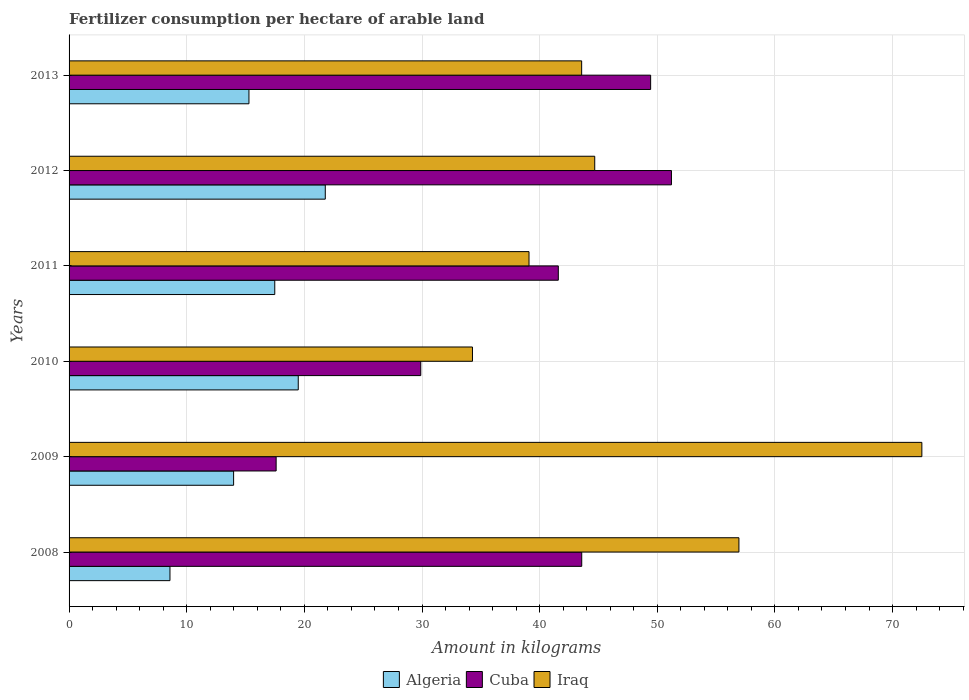How many groups of bars are there?
Offer a very short reply. 6. Are the number of bars per tick equal to the number of legend labels?
Offer a terse response. Yes. Are the number of bars on each tick of the Y-axis equal?
Provide a succinct answer. Yes. What is the amount of fertilizer consumption in Iraq in 2012?
Offer a terse response. 44.68. Across all years, what is the maximum amount of fertilizer consumption in Algeria?
Make the answer very short. 21.78. Across all years, what is the minimum amount of fertilizer consumption in Cuba?
Your response must be concise. 17.6. In which year was the amount of fertilizer consumption in Iraq minimum?
Your response must be concise. 2010. What is the total amount of fertilizer consumption in Algeria in the graph?
Offer a very short reply. 96.6. What is the difference between the amount of fertilizer consumption in Algeria in 2009 and that in 2011?
Keep it short and to the point. -3.5. What is the difference between the amount of fertilizer consumption in Cuba in 2011 and the amount of fertilizer consumption in Algeria in 2013?
Provide a short and direct response. 26.3. What is the average amount of fertilizer consumption in Cuba per year?
Provide a short and direct response. 38.88. In the year 2013, what is the difference between the amount of fertilizer consumption in Iraq and amount of fertilizer consumption in Cuba?
Provide a succinct answer. -5.86. In how many years, is the amount of fertilizer consumption in Cuba greater than 14 kg?
Make the answer very short. 6. What is the ratio of the amount of fertilizer consumption in Iraq in 2009 to that in 2013?
Make the answer very short. 1.66. Is the amount of fertilizer consumption in Algeria in 2010 less than that in 2012?
Offer a very short reply. Yes. Is the difference between the amount of fertilizer consumption in Iraq in 2008 and 2012 greater than the difference between the amount of fertilizer consumption in Cuba in 2008 and 2012?
Ensure brevity in your answer.  Yes. What is the difference between the highest and the second highest amount of fertilizer consumption in Algeria?
Provide a succinct answer. 2.3. What is the difference between the highest and the lowest amount of fertilizer consumption in Cuba?
Make the answer very short. 33.6. What does the 2nd bar from the top in 2013 represents?
Ensure brevity in your answer.  Cuba. What does the 2nd bar from the bottom in 2008 represents?
Make the answer very short. Cuba. Is it the case that in every year, the sum of the amount of fertilizer consumption in Iraq and amount of fertilizer consumption in Algeria is greater than the amount of fertilizer consumption in Cuba?
Ensure brevity in your answer.  Yes. How many bars are there?
Provide a short and direct response. 18. How many years are there in the graph?
Keep it short and to the point. 6. Are the values on the major ticks of X-axis written in scientific E-notation?
Your answer should be compact. No. Where does the legend appear in the graph?
Offer a very short reply. Bottom center. How many legend labels are there?
Your answer should be compact. 3. How are the legend labels stacked?
Your response must be concise. Horizontal. What is the title of the graph?
Give a very brief answer. Fertilizer consumption per hectare of arable land. What is the label or title of the X-axis?
Your response must be concise. Amount in kilograms. What is the Amount in kilograms of Algeria in 2008?
Provide a succinct answer. 8.58. What is the Amount in kilograms of Cuba in 2008?
Offer a very short reply. 43.58. What is the Amount in kilograms of Iraq in 2008?
Your response must be concise. 56.94. What is the Amount in kilograms in Algeria in 2009?
Offer a very short reply. 13.99. What is the Amount in kilograms in Cuba in 2009?
Your answer should be very brief. 17.6. What is the Amount in kilograms of Iraq in 2009?
Your response must be concise. 72.49. What is the Amount in kilograms in Algeria in 2010?
Make the answer very short. 19.48. What is the Amount in kilograms of Cuba in 2010?
Provide a short and direct response. 29.9. What is the Amount in kilograms of Iraq in 2010?
Provide a succinct answer. 34.29. What is the Amount in kilograms of Algeria in 2011?
Your answer should be very brief. 17.49. What is the Amount in kilograms in Cuba in 2011?
Give a very brief answer. 41.59. What is the Amount in kilograms of Iraq in 2011?
Provide a succinct answer. 39.1. What is the Amount in kilograms in Algeria in 2012?
Offer a very short reply. 21.78. What is the Amount in kilograms of Cuba in 2012?
Ensure brevity in your answer.  51.2. What is the Amount in kilograms of Iraq in 2012?
Provide a succinct answer. 44.68. What is the Amount in kilograms in Algeria in 2013?
Provide a short and direct response. 15.29. What is the Amount in kilograms in Cuba in 2013?
Your response must be concise. 49.44. What is the Amount in kilograms of Iraq in 2013?
Your response must be concise. 43.57. Across all years, what is the maximum Amount in kilograms in Algeria?
Ensure brevity in your answer.  21.78. Across all years, what is the maximum Amount in kilograms in Cuba?
Offer a terse response. 51.2. Across all years, what is the maximum Amount in kilograms of Iraq?
Offer a very short reply. 72.49. Across all years, what is the minimum Amount in kilograms of Algeria?
Offer a terse response. 8.58. Across all years, what is the minimum Amount in kilograms of Cuba?
Give a very brief answer. 17.6. Across all years, what is the minimum Amount in kilograms of Iraq?
Your answer should be compact. 34.29. What is the total Amount in kilograms in Algeria in the graph?
Keep it short and to the point. 96.6. What is the total Amount in kilograms in Cuba in the graph?
Ensure brevity in your answer.  233.3. What is the total Amount in kilograms of Iraq in the graph?
Your response must be concise. 291.07. What is the difference between the Amount in kilograms in Algeria in 2008 and that in 2009?
Ensure brevity in your answer.  -5.41. What is the difference between the Amount in kilograms in Cuba in 2008 and that in 2009?
Your answer should be compact. 25.98. What is the difference between the Amount in kilograms of Iraq in 2008 and that in 2009?
Offer a terse response. -15.55. What is the difference between the Amount in kilograms of Algeria in 2008 and that in 2010?
Ensure brevity in your answer.  -10.9. What is the difference between the Amount in kilograms in Cuba in 2008 and that in 2010?
Give a very brief answer. 13.68. What is the difference between the Amount in kilograms of Iraq in 2008 and that in 2010?
Your answer should be very brief. 22.65. What is the difference between the Amount in kilograms in Algeria in 2008 and that in 2011?
Your answer should be very brief. -8.91. What is the difference between the Amount in kilograms of Cuba in 2008 and that in 2011?
Ensure brevity in your answer.  1.99. What is the difference between the Amount in kilograms of Iraq in 2008 and that in 2011?
Provide a succinct answer. 17.84. What is the difference between the Amount in kilograms in Algeria in 2008 and that in 2012?
Provide a short and direct response. -13.2. What is the difference between the Amount in kilograms of Cuba in 2008 and that in 2012?
Your answer should be very brief. -7.63. What is the difference between the Amount in kilograms in Iraq in 2008 and that in 2012?
Offer a terse response. 12.26. What is the difference between the Amount in kilograms in Algeria in 2008 and that in 2013?
Your response must be concise. -6.71. What is the difference between the Amount in kilograms in Cuba in 2008 and that in 2013?
Your answer should be compact. -5.86. What is the difference between the Amount in kilograms in Iraq in 2008 and that in 2013?
Provide a succinct answer. 13.37. What is the difference between the Amount in kilograms of Algeria in 2009 and that in 2010?
Offer a very short reply. -5.49. What is the difference between the Amount in kilograms of Cuba in 2009 and that in 2010?
Provide a short and direct response. -12.29. What is the difference between the Amount in kilograms of Iraq in 2009 and that in 2010?
Provide a short and direct response. 38.2. What is the difference between the Amount in kilograms of Algeria in 2009 and that in 2011?
Ensure brevity in your answer.  -3.5. What is the difference between the Amount in kilograms of Cuba in 2009 and that in 2011?
Give a very brief answer. -23.99. What is the difference between the Amount in kilograms in Iraq in 2009 and that in 2011?
Keep it short and to the point. 33.39. What is the difference between the Amount in kilograms of Algeria in 2009 and that in 2012?
Give a very brief answer. -7.79. What is the difference between the Amount in kilograms of Cuba in 2009 and that in 2012?
Make the answer very short. -33.6. What is the difference between the Amount in kilograms of Iraq in 2009 and that in 2012?
Make the answer very short. 27.81. What is the difference between the Amount in kilograms of Algeria in 2009 and that in 2013?
Provide a succinct answer. -1.3. What is the difference between the Amount in kilograms of Cuba in 2009 and that in 2013?
Your response must be concise. -31.83. What is the difference between the Amount in kilograms of Iraq in 2009 and that in 2013?
Ensure brevity in your answer.  28.92. What is the difference between the Amount in kilograms of Algeria in 2010 and that in 2011?
Offer a terse response. 2. What is the difference between the Amount in kilograms in Cuba in 2010 and that in 2011?
Your response must be concise. -11.69. What is the difference between the Amount in kilograms in Iraq in 2010 and that in 2011?
Provide a short and direct response. -4.81. What is the difference between the Amount in kilograms in Algeria in 2010 and that in 2012?
Your response must be concise. -2.3. What is the difference between the Amount in kilograms of Cuba in 2010 and that in 2012?
Your answer should be very brief. -21.31. What is the difference between the Amount in kilograms in Iraq in 2010 and that in 2012?
Ensure brevity in your answer.  -10.39. What is the difference between the Amount in kilograms in Algeria in 2010 and that in 2013?
Your response must be concise. 4.19. What is the difference between the Amount in kilograms in Cuba in 2010 and that in 2013?
Offer a terse response. -19.54. What is the difference between the Amount in kilograms in Iraq in 2010 and that in 2013?
Keep it short and to the point. -9.28. What is the difference between the Amount in kilograms in Algeria in 2011 and that in 2012?
Provide a succinct answer. -4.29. What is the difference between the Amount in kilograms in Cuba in 2011 and that in 2012?
Provide a short and direct response. -9.62. What is the difference between the Amount in kilograms in Iraq in 2011 and that in 2012?
Give a very brief answer. -5.59. What is the difference between the Amount in kilograms in Algeria in 2011 and that in 2013?
Provide a succinct answer. 2.19. What is the difference between the Amount in kilograms of Cuba in 2011 and that in 2013?
Offer a very short reply. -7.85. What is the difference between the Amount in kilograms in Iraq in 2011 and that in 2013?
Ensure brevity in your answer.  -4.47. What is the difference between the Amount in kilograms of Algeria in 2012 and that in 2013?
Keep it short and to the point. 6.49. What is the difference between the Amount in kilograms of Cuba in 2012 and that in 2013?
Your answer should be compact. 1.77. What is the difference between the Amount in kilograms in Iraq in 2012 and that in 2013?
Provide a succinct answer. 1.11. What is the difference between the Amount in kilograms of Algeria in 2008 and the Amount in kilograms of Cuba in 2009?
Provide a short and direct response. -9.03. What is the difference between the Amount in kilograms in Algeria in 2008 and the Amount in kilograms in Iraq in 2009?
Make the answer very short. -63.91. What is the difference between the Amount in kilograms in Cuba in 2008 and the Amount in kilograms in Iraq in 2009?
Your response must be concise. -28.91. What is the difference between the Amount in kilograms of Algeria in 2008 and the Amount in kilograms of Cuba in 2010?
Your response must be concise. -21.32. What is the difference between the Amount in kilograms of Algeria in 2008 and the Amount in kilograms of Iraq in 2010?
Your response must be concise. -25.71. What is the difference between the Amount in kilograms in Cuba in 2008 and the Amount in kilograms in Iraq in 2010?
Your answer should be compact. 9.29. What is the difference between the Amount in kilograms in Algeria in 2008 and the Amount in kilograms in Cuba in 2011?
Your response must be concise. -33.01. What is the difference between the Amount in kilograms of Algeria in 2008 and the Amount in kilograms of Iraq in 2011?
Ensure brevity in your answer.  -30.52. What is the difference between the Amount in kilograms in Cuba in 2008 and the Amount in kilograms in Iraq in 2011?
Make the answer very short. 4.48. What is the difference between the Amount in kilograms of Algeria in 2008 and the Amount in kilograms of Cuba in 2012?
Keep it short and to the point. -42.63. What is the difference between the Amount in kilograms in Algeria in 2008 and the Amount in kilograms in Iraq in 2012?
Offer a terse response. -36.11. What is the difference between the Amount in kilograms in Cuba in 2008 and the Amount in kilograms in Iraq in 2012?
Your answer should be very brief. -1.11. What is the difference between the Amount in kilograms in Algeria in 2008 and the Amount in kilograms in Cuba in 2013?
Make the answer very short. -40.86. What is the difference between the Amount in kilograms of Algeria in 2008 and the Amount in kilograms of Iraq in 2013?
Make the answer very short. -35. What is the difference between the Amount in kilograms of Cuba in 2008 and the Amount in kilograms of Iraq in 2013?
Offer a terse response. 0.01. What is the difference between the Amount in kilograms in Algeria in 2009 and the Amount in kilograms in Cuba in 2010?
Offer a terse response. -15.91. What is the difference between the Amount in kilograms of Algeria in 2009 and the Amount in kilograms of Iraq in 2010?
Offer a very short reply. -20.3. What is the difference between the Amount in kilograms of Cuba in 2009 and the Amount in kilograms of Iraq in 2010?
Make the answer very short. -16.69. What is the difference between the Amount in kilograms of Algeria in 2009 and the Amount in kilograms of Cuba in 2011?
Offer a very short reply. -27.6. What is the difference between the Amount in kilograms of Algeria in 2009 and the Amount in kilograms of Iraq in 2011?
Keep it short and to the point. -25.11. What is the difference between the Amount in kilograms of Cuba in 2009 and the Amount in kilograms of Iraq in 2011?
Your answer should be very brief. -21.5. What is the difference between the Amount in kilograms in Algeria in 2009 and the Amount in kilograms in Cuba in 2012?
Keep it short and to the point. -37.22. What is the difference between the Amount in kilograms of Algeria in 2009 and the Amount in kilograms of Iraq in 2012?
Give a very brief answer. -30.7. What is the difference between the Amount in kilograms of Cuba in 2009 and the Amount in kilograms of Iraq in 2012?
Ensure brevity in your answer.  -27.08. What is the difference between the Amount in kilograms in Algeria in 2009 and the Amount in kilograms in Cuba in 2013?
Make the answer very short. -35.45. What is the difference between the Amount in kilograms in Algeria in 2009 and the Amount in kilograms in Iraq in 2013?
Make the answer very short. -29.59. What is the difference between the Amount in kilograms of Cuba in 2009 and the Amount in kilograms of Iraq in 2013?
Keep it short and to the point. -25.97. What is the difference between the Amount in kilograms in Algeria in 2010 and the Amount in kilograms in Cuba in 2011?
Your answer should be very brief. -22.11. What is the difference between the Amount in kilograms in Algeria in 2010 and the Amount in kilograms in Iraq in 2011?
Your response must be concise. -19.62. What is the difference between the Amount in kilograms of Cuba in 2010 and the Amount in kilograms of Iraq in 2011?
Your answer should be very brief. -9.2. What is the difference between the Amount in kilograms in Algeria in 2010 and the Amount in kilograms in Cuba in 2012?
Offer a very short reply. -31.72. What is the difference between the Amount in kilograms of Algeria in 2010 and the Amount in kilograms of Iraq in 2012?
Provide a short and direct response. -25.2. What is the difference between the Amount in kilograms in Cuba in 2010 and the Amount in kilograms in Iraq in 2012?
Provide a short and direct response. -14.79. What is the difference between the Amount in kilograms in Algeria in 2010 and the Amount in kilograms in Cuba in 2013?
Provide a succinct answer. -29.95. What is the difference between the Amount in kilograms in Algeria in 2010 and the Amount in kilograms in Iraq in 2013?
Offer a terse response. -24.09. What is the difference between the Amount in kilograms in Cuba in 2010 and the Amount in kilograms in Iraq in 2013?
Provide a short and direct response. -13.68. What is the difference between the Amount in kilograms of Algeria in 2011 and the Amount in kilograms of Cuba in 2012?
Provide a succinct answer. -33.72. What is the difference between the Amount in kilograms of Algeria in 2011 and the Amount in kilograms of Iraq in 2012?
Keep it short and to the point. -27.2. What is the difference between the Amount in kilograms of Cuba in 2011 and the Amount in kilograms of Iraq in 2012?
Ensure brevity in your answer.  -3.1. What is the difference between the Amount in kilograms in Algeria in 2011 and the Amount in kilograms in Cuba in 2013?
Your response must be concise. -31.95. What is the difference between the Amount in kilograms in Algeria in 2011 and the Amount in kilograms in Iraq in 2013?
Offer a terse response. -26.09. What is the difference between the Amount in kilograms in Cuba in 2011 and the Amount in kilograms in Iraq in 2013?
Make the answer very short. -1.98. What is the difference between the Amount in kilograms in Algeria in 2012 and the Amount in kilograms in Cuba in 2013?
Make the answer very short. -27.66. What is the difference between the Amount in kilograms of Algeria in 2012 and the Amount in kilograms of Iraq in 2013?
Make the answer very short. -21.79. What is the difference between the Amount in kilograms in Cuba in 2012 and the Amount in kilograms in Iraq in 2013?
Your answer should be compact. 7.63. What is the average Amount in kilograms in Algeria per year?
Offer a very short reply. 16.1. What is the average Amount in kilograms of Cuba per year?
Offer a very short reply. 38.88. What is the average Amount in kilograms in Iraq per year?
Offer a terse response. 48.51. In the year 2008, what is the difference between the Amount in kilograms of Algeria and Amount in kilograms of Cuba?
Your response must be concise. -35. In the year 2008, what is the difference between the Amount in kilograms of Algeria and Amount in kilograms of Iraq?
Offer a very short reply. -48.36. In the year 2008, what is the difference between the Amount in kilograms in Cuba and Amount in kilograms in Iraq?
Offer a terse response. -13.36. In the year 2009, what is the difference between the Amount in kilograms of Algeria and Amount in kilograms of Cuba?
Ensure brevity in your answer.  -3.62. In the year 2009, what is the difference between the Amount in kilograms of Algeria and Amount in kilograms of Iraq?
Your answer should be compact. -58.5. In the year 2009, what is the difference between the Amount in kilograms of Cuba and Amount in kilograms of Iraq?
Make the answer very short. -54.89. In the year 2010, what is the difference between the Amount in kilograms of Algeria and Amount in kilograms of Cuba?
Keep it short and to the point. -10.41. In the year 2010, what is the difference between the Amount in kilograms in Algeria and Amount in kilograms in Iraq?
Give a very brief answer. -14.81. In the year 2010, what is the difference between the Amount in kilograms of Cuba and Amount in kilograms of Iraq?
Ensure brevity in your answer.  -4.39. In the year 2011, what is the difference between the Amount in kilograms in Algeria and Amount in kilograms in Cuba?
Your response must be concise. -24.1. In the year 2011, what is the difference between the Amount in kilograms of Algeria and Amount in kilograms of Iraq?
Your response must be concise. -21.61. In the year 2011, what is the difference between the Amount in kilograms in Cuba and Amount in kilograms in Iraq?
Your answer should be very brief. 2.49. In the year 2012, what is the difference between the Amount in kilograms in Algeria and Amount in kilograms in Cuba?
Offer a terse response. -29.43. In the year 2012, what is the difference between the Amount in kilograms in Algeria and Amount in kilograms in Iraq?
Offer a very short reply. -22.9. In the year 2012, what is the difference between the Amount in kilograms in Cuba and Amount in kilograms in Iraq?
Ensure brevity in your answer.  6.52. In the year 2013, what is the difference between the Amount in kilograms in Algeria and Amount in kilograms in Cuba?
Give a very brief answer. -34.15. In the year 2013, what is the difference between the Amount in kilograms of Algeria and Amount in kilograms of Iraq?
Make the answer very short. -28.28. In the year 2013, what is the difference between the Amount in kilograms in Cuba and Amount in kilograms in Iraq?
Ensure brevity in your answer.  5.86. What is the ratio of the Amount in kilograms of Algeria in 2008 to that in 2009?
Offer a terse response. 0.61. What is the ratio of the Amount in kilograms in Cuba in 2008 to that in 2009?
Offer a very short reply. 2.48. What is the ratio of the Amount in kilograms of Iraq in 2008 to that in 2009?
Make the answer very short. 0.79. What is the ratio of the Amount in kilograms in Algeria in 2008 to that in 2010?
Provide a short and direct response. 0.44. What is the ratio of the Amount in kilograms of Cuba in 2008 to that in 2010?
Provide a succinct answer. 1.46. What is the ratio of the Amount in kilograms in Iraq in 2008 to that in 2010?
Make the answer very short. 1.66. What is the ratio of the Amount in kilograms in Algeria in 2008 to that in 2011?
Ensure brevity in your answer.  0.49. What is the ratio of the Amount in kilograms of Cuba in 2008 to that in 2011?
Ensure brevity in your answer.  1.05. What is the ratio of the Amount in kilograms in Iraq in 2008 to that in 2011?
Your response must be concise. 1.46. What is the ratio of the Amount in kilograms of Algeria in 2008 to that in 2012?
Make the answer very short. 0.39. What is the ratio of the Amount in kilograms in Cuba in 2008 to that in 2012?
Give a very brief answer. 0.85. What is the ratio of the Amount in kilograms of Iraq in 2008 to that in 2012?
Ensure brevity in your answer.  1.27. What is the ratio of the Amount in kilograms of Algeria in 2008 to that in 2013?
Your answer should be very brief. 0.56. What is the ratio of the Amount in kilograms in Cuba in 2008 to that in 2013?
Provide a succinct answer. 0.88. What is the ratio of the Amount in kilograms in Iraq in 2008 to that in 2013?
Offer a very short reply. 1.31. What is the ratio of the Amount in kilograms of Algeria in 2009 to that in 2010?
Offer a very short reply. 0.72. What is the ratio of the Amount in kilograms in Cuba in 2009 to that in 2010?
Your answer should be compact. 0.59. What is the ratio of the Amount in kilograms of Iraq in 2009 to that in 2010?
Give a very brief answer. 2.11. What is the ratio of the Amount in kilograms of Algeria in 2009 to that in 2011?
Your answer should be very brief. 0.8. What is the ratio of the Amount in kilograms of Cuba in 2009 to that in 2011?
Provide a short and direct response. 0.42. What is the ratio of the Amount in kilograms of Iraq in 2009 to that in 2011?
Your answer should be very brief. 1.85. What is the ratio of the Amount in kilograms in Algeria in 2009 to that in 2012?
Your answer should be very brief. 0.64. What is the ratio of the Amount in kilograms in Cuba in 2009 to that in 2012?
Offer a very short reply. 0.34. What is the ratio of the Amount in kilograms in Iraq in 2009 to that in 2012?
Offer a very short reply. 1.62. What is the ratio of the Amount in kilograms of Algeria in 2009 to that in 2013?
Offer a terse response. 0.91. What is the ratio of the Amount in kilograms of Cuba in 2009 to that in 2013?
Your response must be concise. 0.36. What is the ratio of the Amount in kilograms in Iraq in 2009 to that in 2013?
Your answer should be compact. 1.66. What is the ratio of the Amount in kilograms of Algeria in 2010 to that in 2011?
Keep it short and to the point. 1.11. What is the ratio of the Amount in kilograms in Cuba in 2010 to that in 2011?
Offer a terse response. 0.72. What is the ratio of the Amount in kilograms in Iraq in 2010 to that in 2011?
Your answer should be very brief. 0.88. What is the ratio of the Amount in kilograms of Algeria in 2010 to that in 2012?
Offer a very short reply. 0.89. What is the ratio of the Amount in kilograms in Cuba in 2010 to that in 2012?
Provide a short and direct response. 0.58. What is the ratio of the Amount in kilograms of Iraq in 2010 to that in 2012?
Offer a terse response. 0.77. What is the ratio of the Amount in kilograms in Algeria in 2010 to that in 2013?
Your answer should be compact. 1.27. What is the ratio of the Amount in kilograms of Cuba in 2010 to that in 2013?
Provide a short and direct response. 0.6. What is the ratio of the Amount in kilograms in Iraq in 2010 to that in 2013?
Ensure brevity in your answer.  0.79. What is the ratio of the Amount in kilograms of Algeria in 2011 to that in 2012?
Offer a very short reply. 0.8. What is the ratio of the Amount in kilograms in Cuba in 2011 to that in 2012?
Your answer should be compact. 0.81. What is the ratio of the Amount in kilograms of Iraq in 2011 to that in 2012?
Your response must be concise. 0.88. What is the ratio of the Amount in kilograms of Algeria in 2011 to that in 2013?
Offer a very short reply. 1.14. What is the ratio of the Amount in kilograms of Cuba in 2011 to that in 2013?
Ensure brevity in your answer.  0.84. What is the ratio of the Amount in kilograms of Iraq in 2011 to that in 2013?
Keep it short and to the point. 0.9. What is the ratio of the Amount in kilograms in Algeria in 2012 to that in 2013?
Your answer should be very brief. 1.42. What is the ratio of the Amount in kilograms of Cuba in 2012 to that in 2013?
Your answer should be compact. 1.04. What is the ratio of the Amount in kilograms in Iraq in 2012 to that in 2013?
Offer a very short reply. 1.03. What is the difference between the highest and the second highest Amount in kilograms of Algeria?
Your answer should be compact. 2.3. What is the difference between the highest and the second highest Amount in kilograms of Cuba?
Your answer should be very brief. 1.77. What is the difference between the highest and the second highest Amount in kilograms in Iraq?
Provide a short and direct response. 15.55. What is the difference between the highest and the lowest Amount in kilograms of Algeria?
Offer a very short reply. 13.2. What is the difference between the highest and the lowest Amount in kilograms in Cuba?
Your answer should be very brief. 33.6. What is the difference between the highest and the lowest Amount in kilograms in Iraq?
Provide a short and direct response. 38.2. 